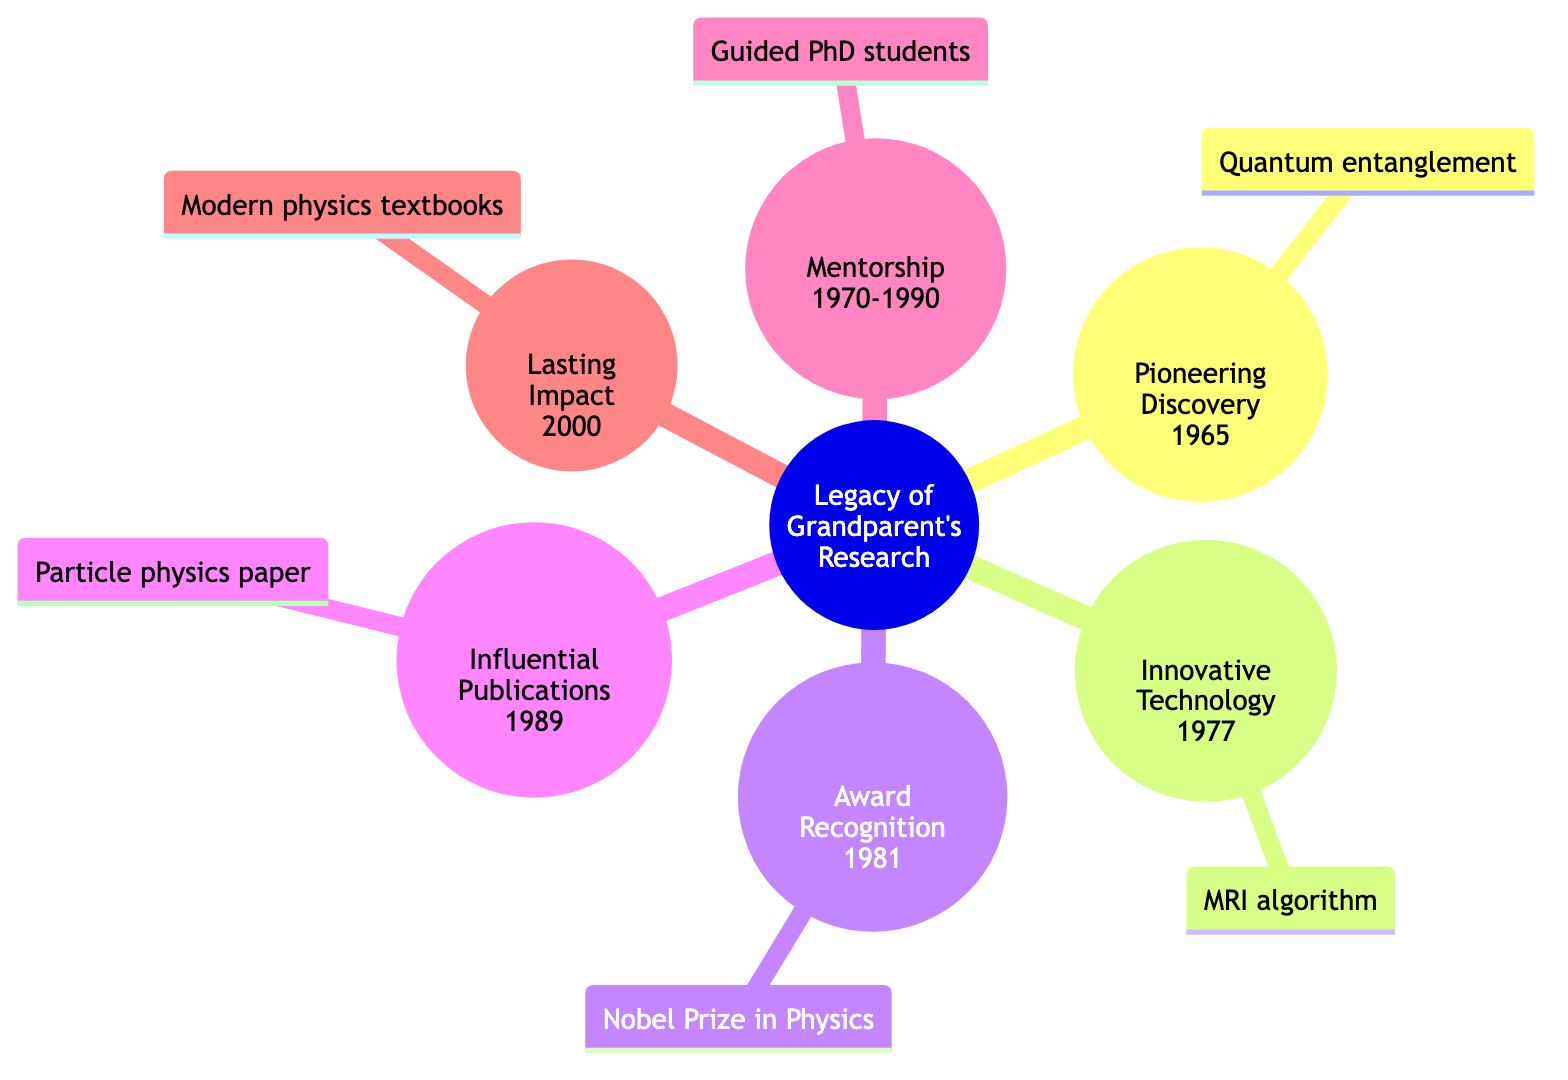What was the year of the Pioneering Discovery? The node labeled "Pioneering Discovery" has the year 1965 noted directly beneath it. This indicates the specific year when this achievement took place.
Answer: 1965 How many key milestones are listed in the diagram? To find the number of key milestones, we can count the distinct categories shown in the mind map: Pioneering Discovery, Innovative Technology, Award Recognition, Influential Publications, Mentorship, and Lasting Impact, totaling six.
Answer: 6 What recognition did Grandparent receive in 1981? The node for the year 1981 is labeled "Award Recognition," which states that Grandparent received the Nobel Prize in Physics during that year.
Answer: Nobel Prize in Physics Which achievement was made in 2000? The Lasting Impact node denotes the year 2000 and specifies the achievement as "Impact on Modern Physics." This indicates that in 2000, their research greatly influenced the field.
Answer: Impact on Modern Physics Who did Grandparent mentor during the years 1970 to 1990? The Mentorship milestone covers a range of years and is detailed as guiding numerous PhD students. This means that during this time period, Grandparent's focus was on mentoring these students.
Answer: PhD students What subject did the influential publication from 1989 focus on? The node for Influential Publications specifies that the seminal paper published in 1989 focused on "Particle Physics," which directly indicates the subject matter of this publication.
Answer: Particle Physics Which two achievements occurred in the same decade? By examining the years of the achievements, we find that both the Innovative Technology in 1977 and Award Recognition in 1981 fall within the 1970s/1980s decade. This means they occurred in the same decade.
Answer: 1970s/1980s What did Grandparent contribute to the development of MRI technology? The Innovative Technology milestone highlights that Grandparent contributed to the algorithm that underpins modern MRI machines, specifying their key role in this development.
Answer: Algorithm for MRI machines In which year was the seminal paper on particle interactions published? The Influential Publications milestone clearly states that the paper was published in 1989, identifying the exact year of publication.
Answer: 1989 